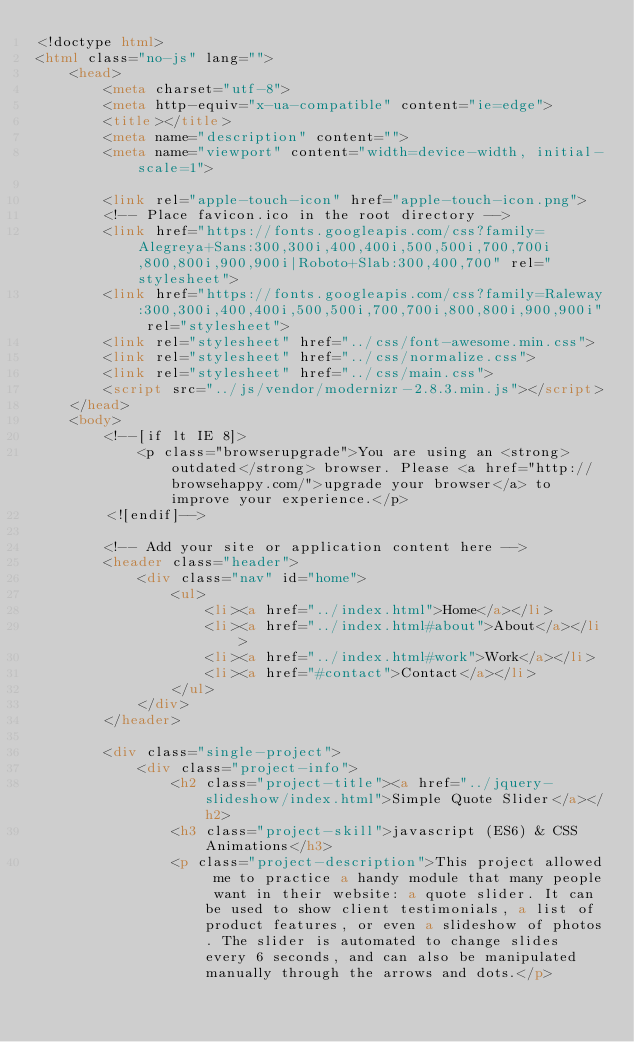<code> <loc_0><loc_0><loc_500><loc_500><_HTML_><!doctype html>
<html class="no-js" lang="">
    <head>
        <meta charset="utf-8">
        <meta http-equiv="x-ua-compatible" content="ie=edge">
        <title></title>
        <meta name="description" content="">
        <meta name="viewport" content="width=device-width, initial-scale=1">

        <link rel="apple-touch-icon" href="apple-touch-icon.png">
        <!-- Place favicon.ico in the root directory -->
        <link href="https://fonts.googleapis.com/css?family=Alegreya+Sans:300,300i,400,400i,500,500i,700,700i,800,800i,900,900i|Roboto+Slab:300,400,700" rel="stylesheet">
        <link href="https://fonts.googleapis.com/css?family=Raleway:300,300i,400,400i,500,500i,700,700i,800,800i,900,900i" rel="stylesheet">
        <link rel="stylesheet" href="../css/font-awesome.min.css">
        <link rel="stylesheet" href="../css/normalize.css">
        <link rel="stylesheet" href="../css/main.css">
        <script src="../js/vendor/modernizr-2.8.3.min.js"></script>
    </head>
    <body>
        <!--[if lt IE 8]>
            <p class="browserupgrade">You are using an <strong>outdated</strong> browser. Please <a href="http://browsehappy.com/">upgrade your browser</a> to improve your experience.</p>
        <![endif]-->

        <!-- Add your site or application content here -->
        <header class="header">
            <div class="nav" id="home">
                <ul>
                    <li><a href="../index.html">Home</a></li>
                    <li><a href="../index.html#about">About</a></li>
                    <li><a href="../index.html#work">Work</a></li>
                    <li><a href="#contact">Contact</a></li>
                </ul>
            </div>
        </header>
        
        <div class="single-project">
            <div class="project-info">
                <h2 class="project-title"><a href="../jquery-slideshow/index.html">Simple Quote Slider</a></h2>
                <h3 class="project-skill">javascript (ES6) & CSS Animations</h3>
                <p class="project-description">This project allowed me to practice a handy module that many people want in their website: a quote slider. It can be used to show client testimonials, a list of product features, or even a slideshow of photos. The slider is automated to change slides every 6 seconds, and can also be manipulated manually through the arrows and dots.</p></code> 